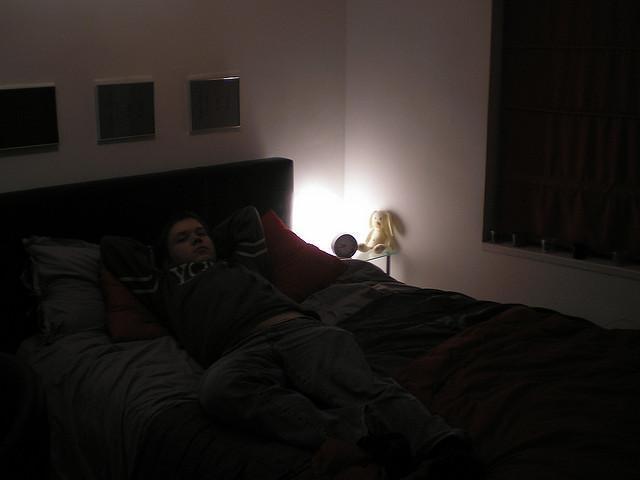Is "The person is touching the teddy bear." an appropriate description for the image?
Answer yes or no. No. 